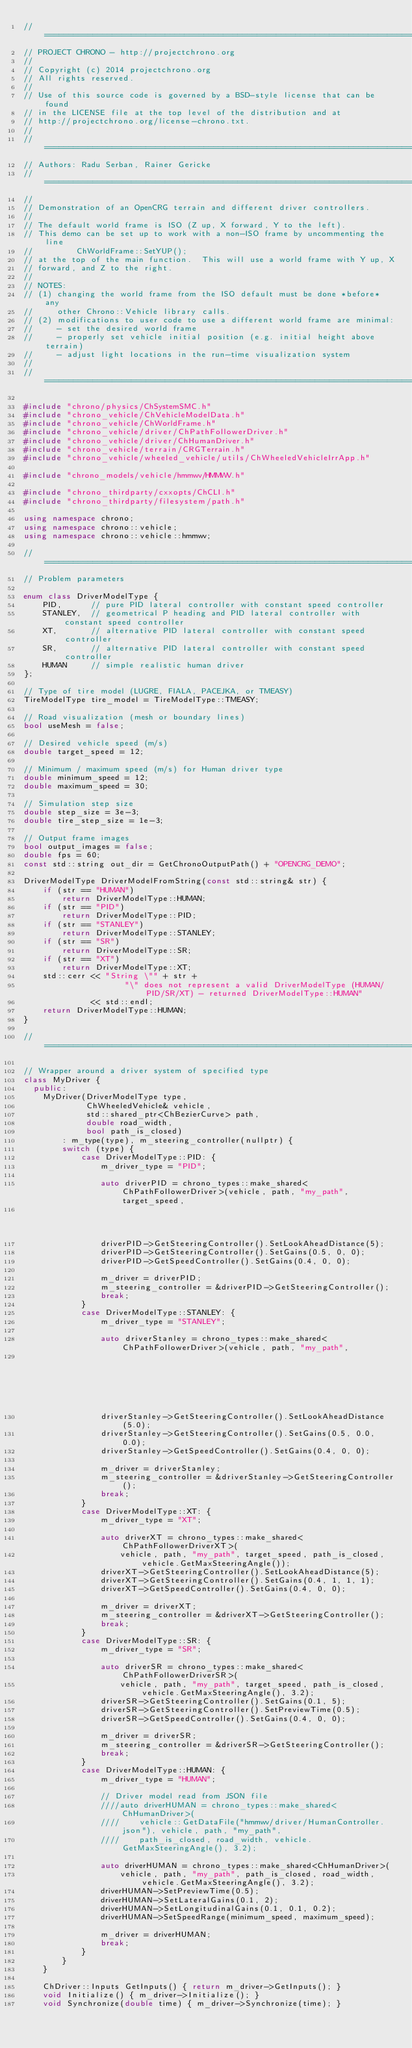<code> <loc_0><loc_0><loc_500><loc_500><_C++_>// =============================================================================
// PROJECT CHRONO - http://projectchrono.org
//
// Copyright (c) 2014 projectchrono.org
// All rights reserved.
//
// Use of this source code is governed by a BSD-style license that can be found
// in the LICENSE file at the top level of the distribution and at
// http://projectchrono.org/license-chrono.txt.
//
// =============================================================================
// Authors: Radu Serban, Rainer Gericke
// =============================================================================
//
// Demonstration of an OpenCRG terrain and different driver controllers.
//
// The default world frame is ISO (Z up, X forward, Y to the left).
// This demo can be set up to work with a non-ISO frame by uncommenting the line
//         ChWorldFrame::SetYUP();
// at the top of the main function.  This will use a world frame with Y up, X
// forward, and Z to the right.
//
// NOTES:
// (1) changing the world frame from the ISO default must be done *before* any
//     other Chrono::Vehicle library calls.
// (2) modifications to user code to use a different world frame are minimal:
//     - set the desired world frame
//     - properly set vehicle initial position (e.g. initial height above terrain)
//     - adjust light locations in the run-time visualization system
//
// =============================================================================

#include "chrono/physics/ChSystemSMC.h"
#include "chrono_vehicle/ChVehicleModelData.h"
#include "chrono_vehicle/ChWorldFrame.h"
#include "chrono_vehicle/driver/ChPathFollowerDriver.h"
#include "chrono_vehicle/driver/ChHumanDriver.h"
#include "chrono_vehicle/terrain/CRGTerrain.h"
#include "chrono_vehicle/wheeled_vehicle/utils/ChWheeledVehicleIrrApp.h"

#include "chrono_models/vehicle/hmmwv/HMMWV.h"

#include "chrono_thirdparty/cxxopts/ChCLI.h"
#include "chrono_thirdparty/filesystem/path.h"

using namespace chrono;
using namespace chrono::vehicle;
using namespace chrono::vehicle::hmmwv;

// =============================================================================
// Problem parameters

enum class DriverModelType {
    PID,      // pure PID lateral controller with constant speed controller
    STANLEY,  // geometrical P heading and PID lateral controller with constant speed controller
    XT,       // alternative PID lateral controller with constant speed controller
    SR,       // alternative PID lateral controller with constant speed controller
    HUMAN     // simple realistic human driver
};

// Type of tire model (LUGRE, FIALA, PACEJKA, or TMEASY)
TireModelType tire_model = TireModelType::TMEASY;

// Road visualization (mesh or boundary lines)
bool useMesh = false;

// Desired vehicle speed (m/s)
double target_speed = 12;

// Minimum / maximum speed (m/s) for Human driver type
double minimum_speed = 12;
double maximum_speed = 30;

// Simulation step size
double step_size = 3e-3;
double tire_step_size = 1e-3;

// Output frame images
bool output_images = false;
double fps = 60;
const std::string out_dir = GetChronoOutputPath() + "OPENCRG_DEMO";

DriverModelType DriverModelFromString(const std::string& str) {
    if (str == "HUMAN")
        return DriverModelType::HUMAN;
    if (str == "PID")
        return DriverModelType::PID;
    if (str == "STANLEY")
        return DriverModelType::STANLEY;
    if (str == "SR")
        return DriverModelType::SR;
    if (str == "XT")
        return DriverModelType::XT;
    std::cerr << "String \"" + str +
                     "\" does not represent a valid DriverModelType (HUMAN/PID/SR/XT) - returned DriverModelType::HUMAN"
              << std::endl;
    return DriverModelType::HUMAN;
}

// =============================================================================

// Wrapper around a driver system of specified type
class MyDriver {
  public:
    MyDriver(DriverModelType type,
             ChWheeledVehicle& vehicle,
             std::shared_ptr<ChBezierCurve> path,
             double road_width,
             bool path_is_closed)
        : m_type(type), m_steering_controller(nullptr) {
        switch (type) {
            case DriverModelType::PID: {
                m_driver_type = "PID";

                auto driverPID = chrono_types::make_shared<ChPathFollowerDriver>(vehicle, path, "my_path", target_speed,
                                                                                 path_is_closed);
                driverPID->GetSteeringController().SetLookAheadDistance(5);
                driverPID->GetSteeringController().SetGains(0.5, 0, 0);
                driverPID->GetSpeedController().SetGains(0.4, 0, 0);

                m_driver = driverPID;
                m_steering_controller = &driverPID->GetSteeringController();
                break;
            }
            case DriverModelType::STANLEY: {
                m_driver_type = "STANLEY";

                auto driverStanley = chrono_types::make_shared<ChPathFollowerDriver>(vehicle, path, "my_path",
                                                                                     target_speed, path_is_closed);
                driverStanley->GetSteeringController().SetLookAheadDistance(5.0);
                driverStanley->GetSteeringController().SetGains(0.5, 0.0, 0.0);
                driverStanley->GetSpeedController().SetGains(0.4, 0, 0);

                m_driver = driverStanley;
                m_steering_controller = &driverStanley->GetSteeringController();
                break;
            }
            case DriverModelType::XT: {
                m_driver_type = "XT";

                auto driverXT = chrono_types::make_shared<ChPathFollowerDriverXT>(
                    vehicle, path, "my_path", target_speed, path_is_closed, vehicle.GetMaxSteeringAngle());
                driverXT->GetSteeringController().SetLookAheadDistance(5);
                driverXT->GetSteeringController().SetGains(0.4, 1, 1, 1);
                driverXT->GetSpeedController().SetGains(0.4, 0, 0);

                m_driver = driverXT;
                m_steering_controller = &driverXT->GetSteeringController();
                break;
            }
            case DriverModelType::SR: {
                m_driver_type = "SR";

                auto driverSR = chrono_types::make_shared<ChPathFollowerDriverSR>(
                    vehicle, path, "my_path", target_speed, path_is_closed, vehicle.GetMaxSteeringAngle(), 3.2);
                driverSR->GetSteeringController().SetGains(0.1, 5);
                driverSR->GetSteeringController().SetPreviewTime(0.5);
                driverSR->GetSpeedController().SetGains(0.4, 0, 0);

                m_driver = driverSR;
                m_steering_controller = &driverSR->GetSteeringController();
                break;
            }
            case DriverModelType::HUMAN: {
                m_driver_type = "HUMAN";

                // Driver model read from JSON file
                ////auto driverHUMAN = chrono_types::make_shared<ChHumanDriver>(
                ////    vehicle::GetDataFile("hmmwv/driver/HumanController.json"), vehicle, path, "my_path",
                ////    path_is_closed, road_width, vehicle.GetMaxSteeringAngle(), 3.2);

                auto driverHUMAN = chrono_types::make_shared<ChHumanDriver>(
                    vehicle, path, "my_path", path_is_closed, road_width, vehicle.GetMaxSteeringAngle(), 3.2);
                driverHUMAN->SetPreviewTime(0.5);
                driverHUMAN->SetLateralGains(0.1, 2);
                driverHUMAN->SetLongitudinalGains(0.1, 0.1, 0.2);
                driverHUMAN->SetSpeedRange(minimum_speed, maximum_speed);

                m_driver = driverHUMAN;
                break;
            }
        }
    }

    ChDriver::Inputs GetInputs() { return m_driver->GetInputs(); }
    void Initialize() { m_driver->Initialize(); }
    void Synchronize(double time) { m_driver->Synchronize(time); }</code> 